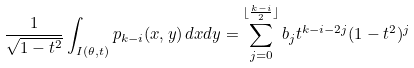<formula> <loc_0><loc_0><loc_500><loc_500>& \frac { 1 } { \sqrt { 1 - t ^ { 2 } } } \int _ { I ( \theta , t ) } p _ { k - i } ( x , y ) \, d x d y = \sum _ { j = 0 } ^ { \lfloor \frac { k - i } { 2 } \rfloor } b _ { j } t ^ { k - i - 2 j } ( 1 - t ^ { 2 } ) ^ { j } &</formula> 